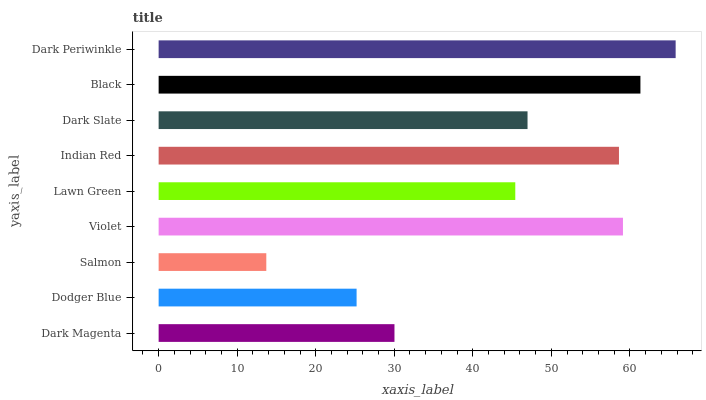Is Salmon the minimum?
Answer yes or no. Yes. Is Dark Periwinkle the maximum?
Answer yes or no. Yes. Is Dodger Blue the minimum?
Answer yes or no. No. Is Dodger Blue the maximum?
Answer yes or no. No. Is Dark Magenta greater than Dodger Blue?
Answer yes or no. Yes. Is Dodger Blue less than Dark Magenta?
Answer yes or no. Yes. Is Dodger Blue greater than Dark Magenta?
Answer yes or no. No. Is Dark Magenta less than Dodger Blue?
Answer yes or no. No. Is Dark Slate the high median?
Answer yes or no. Yes. Is Dark Slate the low median?
Answer yes or no. Yes. Is Dark Periwinkle the high median?
Answer yes or no. No. Is Dark Periwinkle the low median?
Answer yes or no. No. 